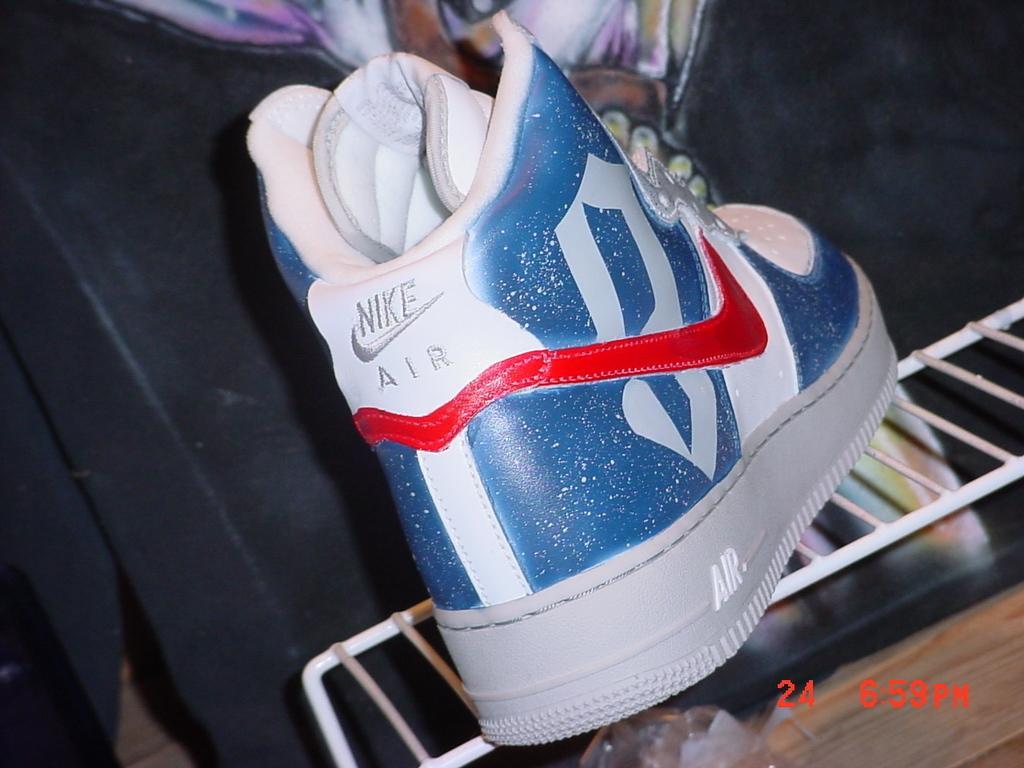How would you summarize this image in a sentence or two? In this image in the foreground there is a shoe, and at the bottom there are some grills. And in the background there is one person and someone objects, at the bottom of the image there is text. 